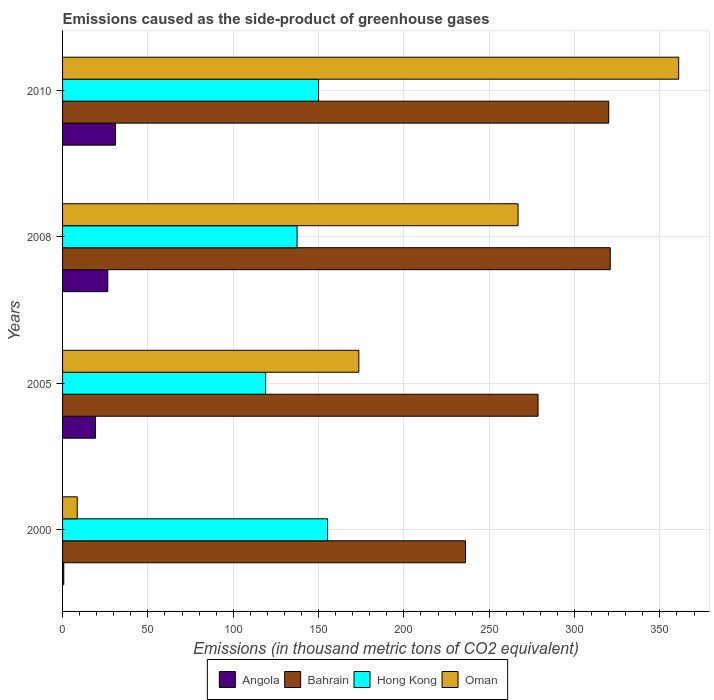How many different coloured bars are there?
Your answer should be very brief. 4. How many bars are there on the 3rd tick from the top?
Provide a succinct answer. 4. What is the label of the 3rd group of bars from the top?
Give a very brief answer. 2005. In how many cases, is the number of bars for a given year not equal to the number of legend labels?
Make the answer very short. 0. What is the emissions caused as the side-product of greenhouse gases in Oman in 2008?
Provide a short and direct response. 266.9. Across all years, what is the maximum emissions caused as the side-product of greenhouse gases in Oman?
Offer a terse response. 361. In which year was the emissions caused as the side-product of greenhouse gases in Angola maximum?
Give a very brief answer. 2010. What is the total emissions caused as the side-product of greenhouse gases in Hong Kong in the graph?
Make the answer very short. 561.7. What is the difference between the emissions caused as the side-product of greenhouse gases in Hong Kong in 2000 and that in 2010?
Your response must be concise. 5.3. What is the difference between the emissions caused as the side-product of greenhouse gases in Oman in 2010 and the emissions caused as the side-product of greenhouse gases in Hong Kong in 2005?
Your response must be concise. 242. What is the average emissions caused as the side-product of greenhouse gases in Hong Kong per year?
Offer a very short reply. 140.43. In the year 2005, what is the difference between the emissions caused as the side-product of greenhouse gases in Hong Kong and emissions caused as the side-product of greenhouse gases in Angola?
Offer a terse response. 99.7. What is the ratio of the emissions caused as the side-product of greenhouse gases in Hong Kong in 2005 to that in 2008?
Ensure brevity in your answer.  0.87. Is the difference between the emissions caused as the side-product of greenhouse gases in Hong Kong in 2000 and 2008 greater than the difference between the emissions caused as the side-product of greenhouse gases in Angola in 2000 and 2008?
Make the answer very short. Yes. What is the difference between the highest and the second highest emissions caused as the side-product of greenhouse gases in Bahrain?
Make the answer very short. 0.9. What is the difference between the highest and the lowest emissions caused as the side-product of greenhouse gases in Oman?
Your answer should be very brief. 352.4. In how many years, is the emissions caused as the side-product of greenhouse gases in Bahrain greater than the average emissions caused as the side-product of greenhouse gases in Bahrain taken over all years?
Ensure brevity in your answer.  2. Is it the case that in every year, the sum of the emissions caused as the side-product of greenhouse gases in Bahrain and emissions caused as the side-product of greenhouse gases in Hong Kong is greater than the sum of emissions caused as the side-product of greenhouse gases in Oman and emissions caused as the side-product of greenhouse gases in Angola?
Keep it short and to the point. Yes. What does the 4th bar from the top in 2008 represents?
Give a very brief answer. Angola. What does the 4th bar from the bottom in 2008 represents?
Offer a very short reply. Oman. Is it the case that in every year, the sum of the emissions caused as the side-product of greenhouse gases in Bahrain and emissions caused as the side-product of greenhouse gases in Hong Kong is greater than the emissions caused as the side-product of greenhouse gases in Oman?
Offer a terse response. Yes. How many bars are there?
Make the answer very short. 16. What is the difference between two consecutive major ticks on the X-axis?
Provide a succinct answer. 50. Does the graph contain any zero values?
Make the answer very short. No. What is the title of the graph?
Make the answer very short. Emissions caused as the side-product of greenhouse gases. What is the label or title of the X-axis?
Offer a terse response. Emissions (in thousand metric tons of CO2 equivalent). What is the label or title of the Y-axis?
Give a very brief answer. Years. What is the Emissions (in thousand metric tons of CO2 equivalent) in Angola in 2000?
Provide a succinct answer. 0.7. What is the Emissions (in thousand metric tons of CO2 equivalent) in Bahrain in 2000?
Your answer should be compact. 236.1. What is the Emissions (in thousand metric tons of CO2 equivalent) in Hong Kong in 2000?
Keep it short and to the point. 155.3. What is the Emissions (in thousand metric tons of CO2 equivalent) of Oman in 2000?
Keep it short and to the point. 8.6. What is the Emissions (in thousand metric tons of CO2 equivalent) of Angola in 2005?
Offer a terse response. 19.3. What is the Emissions (in thousand metric tons of CO2 equivalent) in Bahrain in 2005?
Offer a very short reply. 278.6. What is the Emissions (in thousand metric tons of CO2 equivalent) of Hong Kong in 2005?
Give a very brief answer. 119. What is the Emissions (in thousand metric tons of CO2 equivalent) in Oman in 2005?
Provide a short and direct response. 173.6. What is the Emissions (in thousand metric tons of CO2 equivalent) of Bahrain in 2008?
Offer a terse response. 320.9. What is the Emissions (in thousand metric tons of CO2 equivalent) of Hong Kong in 2008?
Provide a short and direct response. 137.4. What is the Emissions (in thousand metric tons of CO2 equivalent) in Oman in 2008?
Offer a terse response. 266.9. What is the Emissions (in thousand metric tons of CO2 equivalent) in Bahrain in 2010?
Give a very brief answer. 320. What is the Emissions (in thousand metric tons of CO2 equivalent) of Hong Kong in 2010?
Your answer should be compact. 150. What is the Emissions (in thousand metric tons of CO2 equivalent) in Oman in 2010?
Your answer should be compact. 361. Across all years, what is the maximum Emissions (in thousand metric tons of CO2 equivalent) in Bahrain?
Provide a short and direct response. 320.9. Across all years, what is the maximum Emissions (in thousand metric tons of CO2 equivalent) in Hong Kong?
Your answer should be very brief. 155.3. Across all years, what is the maximum Emissions (in thousand metric tons of CO2 equivalent) of Oman?
Keep it short and to the point. 361. Across all years, what is the minimum Emissions (in thousand metric tons of CO2 equivalent) in Bahrain?
Offer a very short reply. 236.1. Across all years, what is the minimum Emissions (in thousand metric tons of CO2 equivalent) in Hong Kong?
Provide a short and direct response. 119. Across all years, what is the minimum Emissions (in thousand metric tons of CO2 equivalent) of Oman?
Your answer should be very brief. 8.6. What is the total Emissions (in thousand metric tons of CO2 equivalent) in Angola in the graph?
Provide a short and direct response. 77.5. What is the total Emissions (in thousand metric tons of CO2 equivalent) in Bahrain in the graph?
Give a very brief answer. 1155.6. What is the total Emissions (in thousand metric tons of CO2 equivalent) in Hong Kong in the graph?
Your response must be concise. 561.7. What is the total Emissions (in thousand metric tons of CO2 equivalent) of Oman in the graph?
Provide a short and direct response. 810.1. What is the difference between the Emissions (in thousand metric tons of CO2 equivalent) in Angola in 2000 and that in 2005?
Your response must be concise. -18.6. What is the difference between the Emissions (in thousand metric tons of CO2 equivalent) of Bahrain in 2000 and that in 2005?
Give a very brief answer. -42.5. What is the difference between the Emissions (in thousand metric tons of CO2 equivalent) of Hong Kong in 2000 and that in 2005?
Your answer should be compact. 36.3. What is the difference between the Emissions (in thousand metric tons of CO2 equivalent) in Oman in 2000 and that in 2005?
Provide a short and direct response. -165. What is the difference between the Emissions (in thousand metric tons of CO2 equivalent) in Angola in 2000 and that in 2008?
Give a very brief answer. -25.8. What is the difference between the Emissions (in thousand metric tons of CO2 equivalent) of Bahrain in 2000 and that in 2008?
Ensure brevity in your answer.  -84.8. What is the difference between the Emissions (in thousand metric tons of CO2 equivalent) in Hong Kong in 2000 and that in 2008?
Keep it short and to the point. 17.9. What is the difference between the Emissions (in thousand metric tons of CO2 equivalent) in Oman in 2000 and that in 2008?
Your response must be concise. -258.3. What is the difference between the Emissions (in thousand metric tons of CO2 equivalent) in Angola in 2000 and that in 2010?
Make the answer very short. -30.3. What is the difference between the Emissions (in thousand metric tons of CO2 equivalent) of Bahrain in 2000 and that in 2010?
Your answer should be very brief. -83.9. What is the difference between the Emissions (in thousand metric tons of CO2 equivalent) in Oman in 2000 and that in 2010?
Give a very brief answer. -352.4. What is the difference between the Emissions (in thousand metric tons of CO2 equivalent) of Angola in 2005 and that in 2008?
Your answer should be compact. -7.2. What is the difference between the Emissions (in thousand metric tons of CO2 equivalent) of Bahrain in 2005 and that in 2008?
Your answer should be very brief. -42.3. What is the difference between the Emissions (in thousand metric tons of CO2 equivalent) in Hong Kong in 2005 and that in 2008?
Provide a short and direct response. -18.4. What is the difference between the Emissions (in thousand metric tons of CO2 equivalent) in Oman in 2005 and that in 2008?
Give a very brief answer. -93.3. What is the difference between the Emissions (in thousand metric tons of CO2 equivalent) of Angola in 2005 and that in 2010?
Provide a short and direct response. -11.7. What is the difference between the Emissions (in thousand metric tons of CO2 equivalent) in Bahrain in 2005 and that in 2010?
Keep it short and to the point. -41.4. What is the difference between the Emissions (in thousand metric tons of CO2 equivalent) of Hong Kong in 2005 and that in 2010?
Ensure brevity in your answer.  -31. What is the difference between the Emissions (in thousand metric tons of CO2 equivalent) of Oman in 2005 and that in 2010?
Provide a succinct answer. -187.4. What is the difference between the Emissions (in thousand metric tons of CO2 equivalent) of Angola in 2008 and that in 2010?
Give a very brief answer. -4.5. What is the difference between the Emissions (in thousand metric tons of CO2 equivalent) of Oman in 2008 and that in 2010?
Your response must be concise. -94.1. What is the difference between the Emissions (in thousand metric tons of CO2 equivalent) of Angola in 2000 and the Emissions (in thousand metric tons of CO2 equivalent) of Bahrain in 2005?
Provide a succinct answer. -277.9. What is the difference between the Emissions (in thousand metric tons of CO2 equivalent) in Angola in 2000 and the Emissions (in thousand metric tons of CO2 equivalent) in Hong Kong in 2005?
Provide a succinct answer. -118.3. What is the difference between the Emissions (in thousand metric tons of CO2 equivalent) of Angola in 2000 and the Emissions (in thousand metric tons of CO2 equivalent) of Oman in 2005?
Provide a succinct answer. -172.9. What is the difference between the Emissions (in thousand metric tons of CO2 equivalent) of Bahrain in 2000 and the Emissions (in thousand metric tons of CO2 equivalent) of Hong Kong in 2005?
Offer a very short reply. 117.1. What is the difference between the Emissions (in thousand metric tons of CO2 equivalent) of Bahrain in 2000 and the Emissions (in thousand metric tons of CO2 equivalent) of Oman in 2005?
Provide a short and direct response. 62.5. What is the difference between the Emissions (in thousand metric tons of CO2 equivalent) of Hong Kong in 2000 and the Emissions (in thousand metric tons of CO2 equivalent) of Oman in 2005?
Your response must be concise. -18.3. What is the difference between the Emissions (in thousand metric tons of CO2 equivalent) in Angola in 2000 and the Emissions (in thousand metric tons of CO2 equivalent) in Bahrain in 2008?
Make the answer very short. -320.2. What is the difference between the Emissions (in thousand metric tons of CO2 equivalent) in Angola in 2000 and the Emissions (in thousand metric tons of CO2 equivalent) in Hong Kong in 2008?
Offer a terse response. -136.7. What is the difference between the Emissions (in thousand metric tons of CO2 equivalent) of Angola in 2000 and the Emissions (in thousand metric tons of CO2 equivalent) of Oman in 2008?
Keep it short and to the point. -266.2. What is the difference between the Emissions (in thousand metric tons of CO2 equivalent) of Bahrain in 2000 and the Emissions (in thousand metric tons of CO2 equivalent) of Hong Kong in 2008?
Your response must be concise. 98.7. What is the difference between the Emissions (in thousand metric tons of CO2 equivalent) of Bahrain in 2000 and the Emissions (in thousand metric tons of CO2 equivalent) of Oman in 2008?
Offer a very short reply. -30.8. What is the difference between the Emissions (in thousand metric tons of CO2 equivalent) of Hong Kong in 2000 and the Emissions (in thousand metric tons of CO2 equivalent) of Oman in 2008?
Your response must be concise. -111.6. What is the difference between the Emissions (in thousand metric tons of CO2 equivalent) in Angola in 2000 and the Emissions (in thousand metric tons of CO2 equivalent) in Bahrain in 2010?
Give a very brief answer. -319.3. What is the difference between the Emissions (in thousand metric tons of CO2 equivalent) of Angola in 2000 and the Emissions (in thousand metric tons of CO2 equivalent) of Hong Kong in 2010?
Your answer should be compact. -149.3. What is the difference between the Emissions (in thousand metric tons of CO2 equivalent) in Angola in 2000 and the Emissions (in thousand metric tons of CO2 equivalent) in Oman in 2010?
Keep it short and to the point. -360.3. What is the difference between the Emissions (in thousand metric tons of CO2 equivalent) in Bahrain in 2000 and the Emissions (in thousand metric tons of CO2 equivalent) in Hong Kong in 2010?
Keep it short and to the point. 86.1. What is the difference between the Emissions (in thousand metric tons of CO2 equivalent) in Bahrain in 2000 and the Emissions (in thousand metric tons of CO2 equivalent) in Oman in 2010?
Your answer should be very brief. -124.9. What is the difference between the Emissions (in thousand metric tons of CO2 equivalent) of Hong Kong in 2000 and the Emissions (in thousand metric tons of CO2 equivalent) of Oman in 2010?
Your response must be concise. -205.7. What is the difference between the Emissions (in thousand metric tons of CO2 equivalent) of Angola in 2005 and the Emissions (in thousand metric tons of CO2 equivalent) of Bahrain in 2008?
Keep it short and to the point. -301.6. What is the difference between the Emissions (in thousand metric tons of CO2 equivalent) in Angola in 2005 and the Emissions (in thousand metric tons of CO2 equivalent) in Hong Kong in 2008?
Offer a terse response. -118.1. What is the difference between the Emissions (in thousand metric tons of CO2 equivalent) in Angola in 2005 and the Emissions (in thousand metric tons of CO2 equivalent) in Oman in 2008?
Your answer should be compact. -247.6. What is the difference between the Emissions (in thousand metric tons of CO2 equivalent) in Bahrain in 2005 and the Emissions (in thousand metric tons of CO2 equivalent) in Hong Kong in 2008?
Your response must be concise. 141.2. What is the difference between the Emissions (in thousand metric tons of CO2 equivalent) of Bahrain in 2005 and the Emissions (in thousand metric tons of CO2 equivalent) of Oman in 2008?
Offer a very short reply. 11.7. What is the difference between the Emissions (in thousand metric tons of CO2 equivalent) in Hong Kong in 2005 and the Emissions (in thousand metric tons of CO2 equivalent) in Oman in 2008?
Make the answer very short. -147.9. What is the difference between the Emissions (in thousand metric tons of CO2 equivalent) of Angola in 2005 and the Emissions (in thousand metric tons of CO2 equivalent) of Bahrain in 2010?
Ensure brevity in your answer.  -300.7. What is the difference between the Emissions (in thousand metric tons of CO2 equivalent) of Angola in 2005 and the Emissions (in thousand metric tons of CO2 equivalent) of Hong Kong in 2010?
Make the answer very short. -130.7. What is the difference between the Emissions (in thousand metric tons of CO2 equivalent) in Angola in 2005 and the Emissions (in thousand metric tons of CO2 equivalent) in Oman in 2010?
Keep it short and to the point. -341.7. What is the difference between the Emissions (in thousand metric tons of CO2 equivalent) in Bahrain in 2005 and the Emissions (in thousand metric tons of CO2 equivalent) in Hong Kong in 2010?
Keep it short and to the point. 128.6. What is the difference between the Emissions (in thousand metric tons of CO2 equivalent) in Bahrain in 2005 and the Emissions (in thousand metric tons of CO2 equivalent) in Oman in 2010?
Provide a short and direct response. -82.4. What is the difference between the Emissions (in thousand metric tons of CO2 equivalent) in Hong Kong in 2005 and the Emissions (in thousand metric tons of CO2 equivalent) in Oman in 2010?
Offer a very short reply. -242. What is the difference between the Emissions (in thousand metric tons of CO2 equivalent) of Angola in 2008 and the Emissions (in thousand metric tons of CO2 equivalent) of Bahrain in 2010?
Your answer should be compact. -293.5. What is the difference between the Emissions (in thousand metric tons of CO2 equivalent) in Angola in 2008 and the Emissions (in thousand metric tons of CO2 equivalent) in Hong Kong in 2010?
Give a very brief answer. -123.5. What is the difference between the Emissions (in thousand metric tons of CO2 equivalent) in Angola in 2008 and the Emissions (in thousand metric tons of CO2 equivalent) in Oman in 2010?
Give a very brief answer. -334.5. What is the difference between the Emissions (in thousand metric tons of CO2 equivalent) in Bahrain in 2008 and the Emissions (in thousand metric tons of CO2 equivalent) in Hong Kong in 2010?
Provide a succinct answer. 170.9. What is the difference between the Emissions (in thousand metric tons of CO2 equivalent) in Bahrain in 2008 and the Emissions (in thousand metric tons of CO2 equivalent) in Oman in 2010?
Provide a short and direct response. -40.1. What is the difference between the Emissions (in thousand metric tons of CO2 equivalent) of Hong Kong in 2008 and the Emissions (in thousand metric tons of CO2 equivalent) of Oman in 2010?
Make the answer very short. -223.6. What is the average Emissions (in thousand metric tons of CO2 equivalent) in Angola per year?
Your answer should be compact. 19.38. What is the average Emissions (in thousand metric tons of CO2 equivalent) of Bahrain per year?
Your answer should be very brief. 288.9. What is the average Emissions (in thousand metric tons of CO2 equivalent) in Hong Kong per year?
Ensure brevity in your answer.  140.43. What is the average Emissions (in thousand metric tons of CO2 equivalent) in Oman per year?
Provide a short and direct response. 202.53. In the year 2000, what is the difference between the Emissions (in thousand metric tons of CO2 equivalent) of Angola and Emissions (in thousand metric tons of CO2 equivalent) of Bahrain?
Make the answer very short. -235.4. In the year 2000, what is the difference between the Emissions (in thousand metric tons of CO2 equivalent) of Angola and Emissions (in thousand metric tons of CO2 equivalent) of Hong Kong?
Ensure brevity in your answer.  -154.6. In the year 2000, what is the difference between the Emissions (in thousand metric tons of CO2 equivalent) in Angola and Emissions (in thousand metric tons of CO2 equivalent) in Oman?
Your response must be concise. -7.9. In the year 2000, what is the difference between the Emissions (in thousand metric tons of CO2 equivalent) of Bahrain and Emissions (in thousand metric tons of CO2 equivalent) of Hong Kong?
Give a very brief answer. 80.8. In the year 2000, what is the difference between the Emissions (in thousand metric tons of CO2 equivalent) in Bahrain and Emissions (in thousand metric tons of CO2 equivalent) in Oman?
Keep it short and to the point. 227.5. In the year 2000, what is the difference between the Emissions (in thousand metric tons of CO2 equivalent) of Hong Kong and Emissions (in thousand metric tons of CO2 equivalent) of Oman?
Provide a short and direct response. 146.7. In the year 2005, what is the difference between the Emissions (in thousand metric tons of CO2 equivalent) of Angola and Emissions (in thousand metric tons of CO2 equivalent) of Bahrain?
Offer a very short reply. -259.3. In the year 2005, what is the difference between the Emissions (in thousand metric tons of CO2 equivalent) in Angola and Emissions (in thousand metric tons of CO2 equivalent) in Hong Kong?
Provide a succinct answer. -99.7. In the year 2005, what is the difference between the Emissions (in thousand metric tons of CO2 equivalent) of Angola and Emissions (in thousand metric tons of CO2 equivalent) of Oman?
Give a very brief answer. -154.3. In the year 2005, what is the difference between the Emissions (in thousand metric tons of CO2 equivalent) of Bahrain and Emissions (in thousand metric tons of CO2 equivalent) of Hong Kong?
Provide a short and direct response. 159.6. In the year 2005, what is the difference between the Emissions (in thousand metric tons of CO2 equivalent) of Bahrain and Emissions (in thousand metric tons of CO2 equivalent) of Oman?
Provide a succinct answer. 105. In the year 2005, what is the difference between the Emissions (in thousand metric tons of CO2 equivalent) of Hong Kong and Emissions (in thousand metric tons of CO2 equivalent) of Oman?
Keep it short and to the point. -54.6. In the year 2008, what is the difference between the Emissions (in thousand metric tons of CO2 equivalent) in Angola and Emissions (in thousand metric tons of CO2 equivalent) in Bahrain?
Provide a short and direct response. -294.4. In the year 2008, what is the difference between the Emissions (in thousand metric tons of CO2 equivalent) in Angola and Emissions (in thousand metric tons of CO2 equivalent) in Hong Kong?
Offer a terse response. -110.9. In the year 2008, what is the difference between the Emissions (in thousand metric tons of CO2 equivalent) of Angola and Emissions (in thousand metric tons of CO2 equivalent) of Oman?
Your answer should be compact. -240.4. In the year 2008, what is the difference between the Emissions (in thousand metric tons of CO2 equivalent) in Bahrain and Emissions (in thousand metric tons of CO2 equivalent) in Hong Kong?
Provide a short and direct response. 183.5. In the year 2008, what is the difference between the Emissions (in thousand metric tons of CO2 equivalent) of Hong Kong and Emissions (in thousand metric tons of CO2 equivalent) of Oman?
Provide a short and direct response. -129.5. In the year 2010, what is the difference between the Emissions (in thousand metric tons of CO2 equivalent) in Angola and Emissions (in thousand metric tons of CO2 equivalent) in Bahrain?
Give a very brief answer. -289. In the year 2010, what is the difference between the Emissions (in thousand metric tons of CO2 equivalent) in Angola and Emissions (in thousand metric tons of CO2 equivalent) in Hong Kong?
Provide a succinct answer. -119. In the year 2010, what is the difference between the Emissions (in thousand metric tons of CO2 equivalent) of Angola and Emissions (in thousand metric tons of CO2 equivalent) of Oman?
Your answer should be compact. -330. In the year 2010, what is the difference between the Emissions (in thousand metric tons of CO2 equivalent) of Bahrain and Emissions (in thousand metric tons of CO2 equivalent) of Hong Kong?
Give a very brief answer. 170. In the year 2010, what is the difference between the Emissions (in thousand metric tons of CO2 equivalent) in Bahrain and Emissions (in thousand metric tons of CO2 equivalent) in Oman?
Your answer should be compact. -41. In the year 2010, what is the difference between the Emissions (in thousand metric tons of CO2 equivalent) in Hong Kong and Emissions (in thousand metric tons of CO2 equivalent) in Oman?
Provide a succinct answer. -211. What is the ratio of the Emissions (in thousand metric tons of CO2 equivalent) in Angola in 2000 to that in 2005?
Your response must be concise. 0.04. What is the ratio of the Emissions (in thousand metric tons of CO2 equivalent) in Bahrain in 2000 to that in 2005?
Your answer should be very brief. 0.85. What is the ratio of the Emissions (in thousand metric tons of CO2 equivalent) of Hong Kong in 2000 to that in 2005?
Offer a terse response. 1.3. What is the ratio of the Emissions (in thousand metric tons of CO2 equivalent) of Oman in 2000 to that in 2005?
Ensure brevity in your answer.  0.05. What is the ratio of the Emissions (in thousand metric tons of CO2 equivalent) of Angola in 2000 to that in 2008?
Your answer should be very brief. 0.03. What is the ratio of the Emissions (in thousand metric tons of CO2 equivalent) in Bahrain in 2000 to that in 2008?
Offer a very short reply. 0.74. What is the ratio of the Emissions (in thousand metric tons of CO2 equivalent) in Hong Kong in 2000 to that in 2008?
Your answer should be compact. 1.13. What is the ratio of the Emissions (in thousand metric tons of CO2 equivalent) in Oman in 2000 to that in 2008?
Offer a very short reply. 0.03. What is the ratio of the Emissions (in thousand metric tons of CO2 equivalent) of Angola in 2000 to that in 2010?
Keep it short and to the point. 0.02. What is the ratio of the Emissions (in thousand metric tons of CO2 equivalent) of Bahrain in 2000 to that in 2010?
Provide a succinct answer. 0.74. What is the ratio of the Emissions (in thousand metric tons of CO2 equivalent) in Hong Kong in 2000 to that in 2010?
Ensure brevity in your answer.  1.04. What is the ratio of the Emissions (in thousand metric tons of CO2 equivalent) in Oman in 2000 to that in 2010?
Ensure brevity in your answer.  0.02. What is the ratio of the Emissions (in thousand metric tons of CO2 equivalent) in Angola in 2005 to that in 2008?
Provide a succinct answer. 0.73. What is the ratio of the Emissions (in thousand metric tons of CO2 equivalent) of Bahrain in 2005 to that in 2008?
Give a very brief answer. 0.87. What is the ratio of the Emissions (in thousand metric tons of CO2 equivalent) of Hong Kong in 2005 to that in 2008?
Your answer should be compact. 0.87. What is the ratio of the Emissions (in thousand metric tons of CO2 equivalent) in Oman in 2005 to that in 2008?
Your response must be concise. 0.65. What is the ratio of the Emissions (in thousand metric tons of CO2 equivalent) of Angola in 2005 to that in 2010?
Give a very brief answer. 0.62. What is the ratio of the Emissions (in thousand metric tons of CO2 equivalent) of Bahrain in 2005 to that in 2010?
Offer a very short reply. 0.87. What is the ratio of the Emissions (in thousand metric tons of CO2 equivalent) in Hong Kong in 2005 to that in 2010?
Your answer should be compact. 0.79. What is the ratio of the Emissions (in thousand metric tons of CO2 equivalent) of Oman in 2005 to that in 2010?
Provide a short and direct response. 0.48. What is the ratio of the Emissions (in thousand metric tons of CO2 equivalent) in Angola in 2008 to that in 2010?
Provide a short and direct response. 0.85. What is the ratio of the Emissions (in thousand metric tons of CO2 equivalent) in Bahrain in 2008 to that in 2010?
Provide a succinct answer. 1. What is the ratio of the Emissions (in thousand metric tons of CO2 equivalent) of Hong Kong in 2008 to that in 2010?
Give a very brief answer. 0.92. What is the ratio of the Emissions (in thousand metric tons of CO2 equivalent) of Oman in 2008 to that in 2010?
Give a very brief answer. 0.74. What is the difference between the highest and the second highest Emissions (in thousand metric tons of CO2 equivalent) of Oman?
Keep it short and to the point. 94.1. What is the difference between the highest and the lowest Emissions (in thousand metric tons of CO2 equivalent) of Angola?
Offer a terse response. 30.3. What is the difference between the highest and the lowest Emissions (in thousand metric tons of CO2 equivalent) in Bahrain?
Offer a terse response. 84.8. What is the difference between the highest and the lowest Emissions (in thousand metric tons of CO2 equivalent) of Hong Kong?
Offer a very short reply. 36.3. What is the difference between the highest and the lowest Emissions (in thousand metric tons of CO2 equivalent) in Oman?
Your answer should be compact. 352.4. 